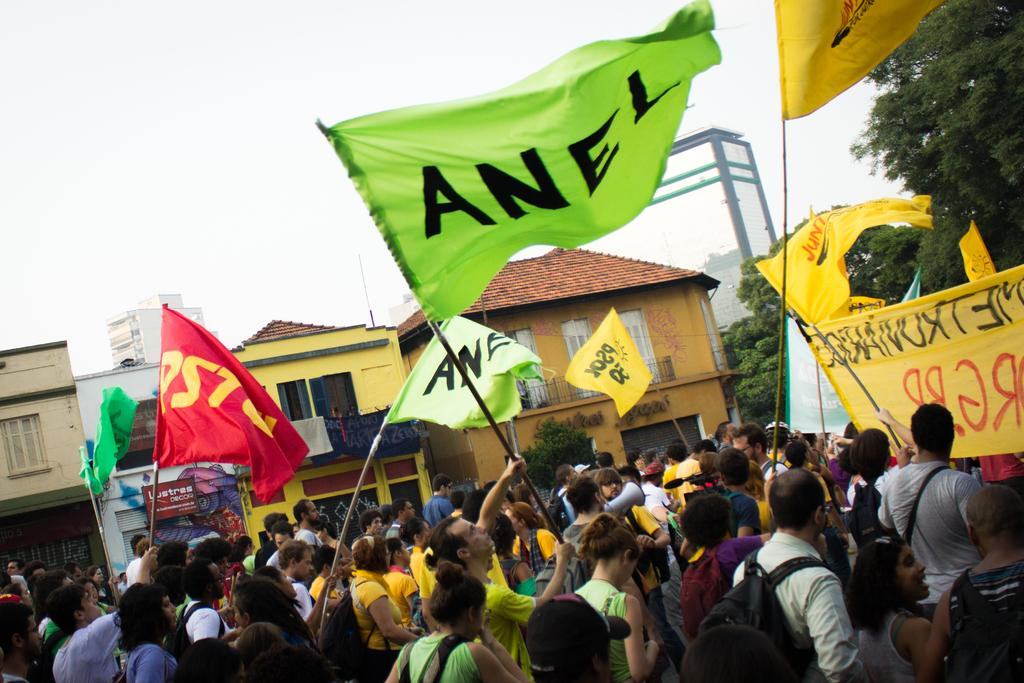What are the people in the image doing? The people in the image are standing and holding flags. What can be seen on the right side of the image? There are trees on the right side of the image. What is visible at the top of the image? The sky is visible at the top of the image. Can you see any mountains in the image? There are no mountains visible in the image. How many kittens are sitting on the shoulders of the people in the image? There are no kittens present in the image. 